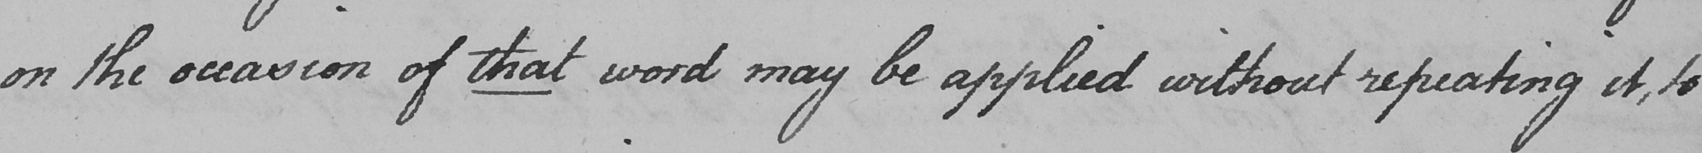Please transcribe the handwritten text in this image. on the occasion of that word may be applied without repeating it , to 